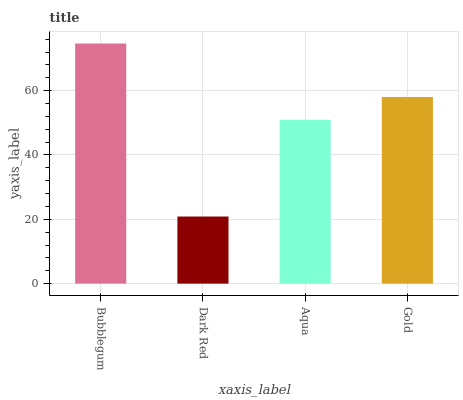Is Dark Red the minimum?
Answer yes or no. Yes. Is Bubblegum the maximum?
Answer yes or no. Yes. Is Aqua the minimum?
Answer yes or no. No. Is Aqua the maximum?
Answer yes or no. No. Is Aqua greater than Dark Red?
Answer yes or no. Yes. Is Dark Red less than Aqua?
Answer yes or no. Yes. Is Dark Red greater than Aqua?
Answer yes or no. No. Is Aqua less than Dark Red?
Answer yes or no. No. Is Gold the high median?
Answer yes or no. Yes. Is Aqua the low median?
Answer yes or no. Yes. Is Bubblegum the high median?
Answer yes or no. No. Is Gold the low median?
Answer yes or no. No. 